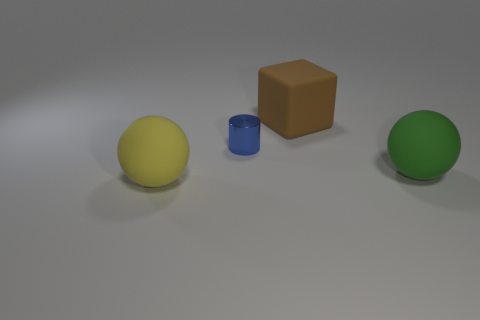Add 4 small blue metallic things. How many objects exist? 8 Subtract all cylinders. How many objects are left? 3 Subtract 0 blue spheres. How many objects are left? 4 Subtract all gray metallic spheres. Subtract all small blue metal objects. How many objects are left? 3 Add 3 large yellow balls. How many large yellow balls are left? 4 Add 1 blue metallic cylinders. How many blue metallic cylinders exist? 2 